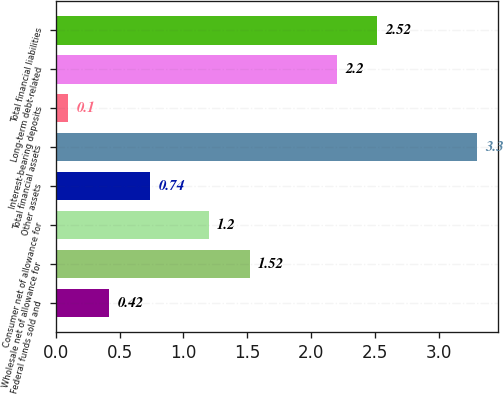Convert chart. <chart><loc_0><loc_0><loc_500><loc_500><bar_chart><fcel>Federal funds sold and<fcel>Wholesale net of allowance for<fcel>Consumer net of allowance for<fcel>Other assets<fcel>Total financial assets<fcel>Interest-bearing deposits<fcel>Long-term debt-related<fcel>Total financial liabilities<nl><fcel>0.42<fcel>1.52<fcel>1.2<fcel>0.74<fcel>3.3<fcel>0.1<fcel>2.2<fcel>2.52<nl></chart> 